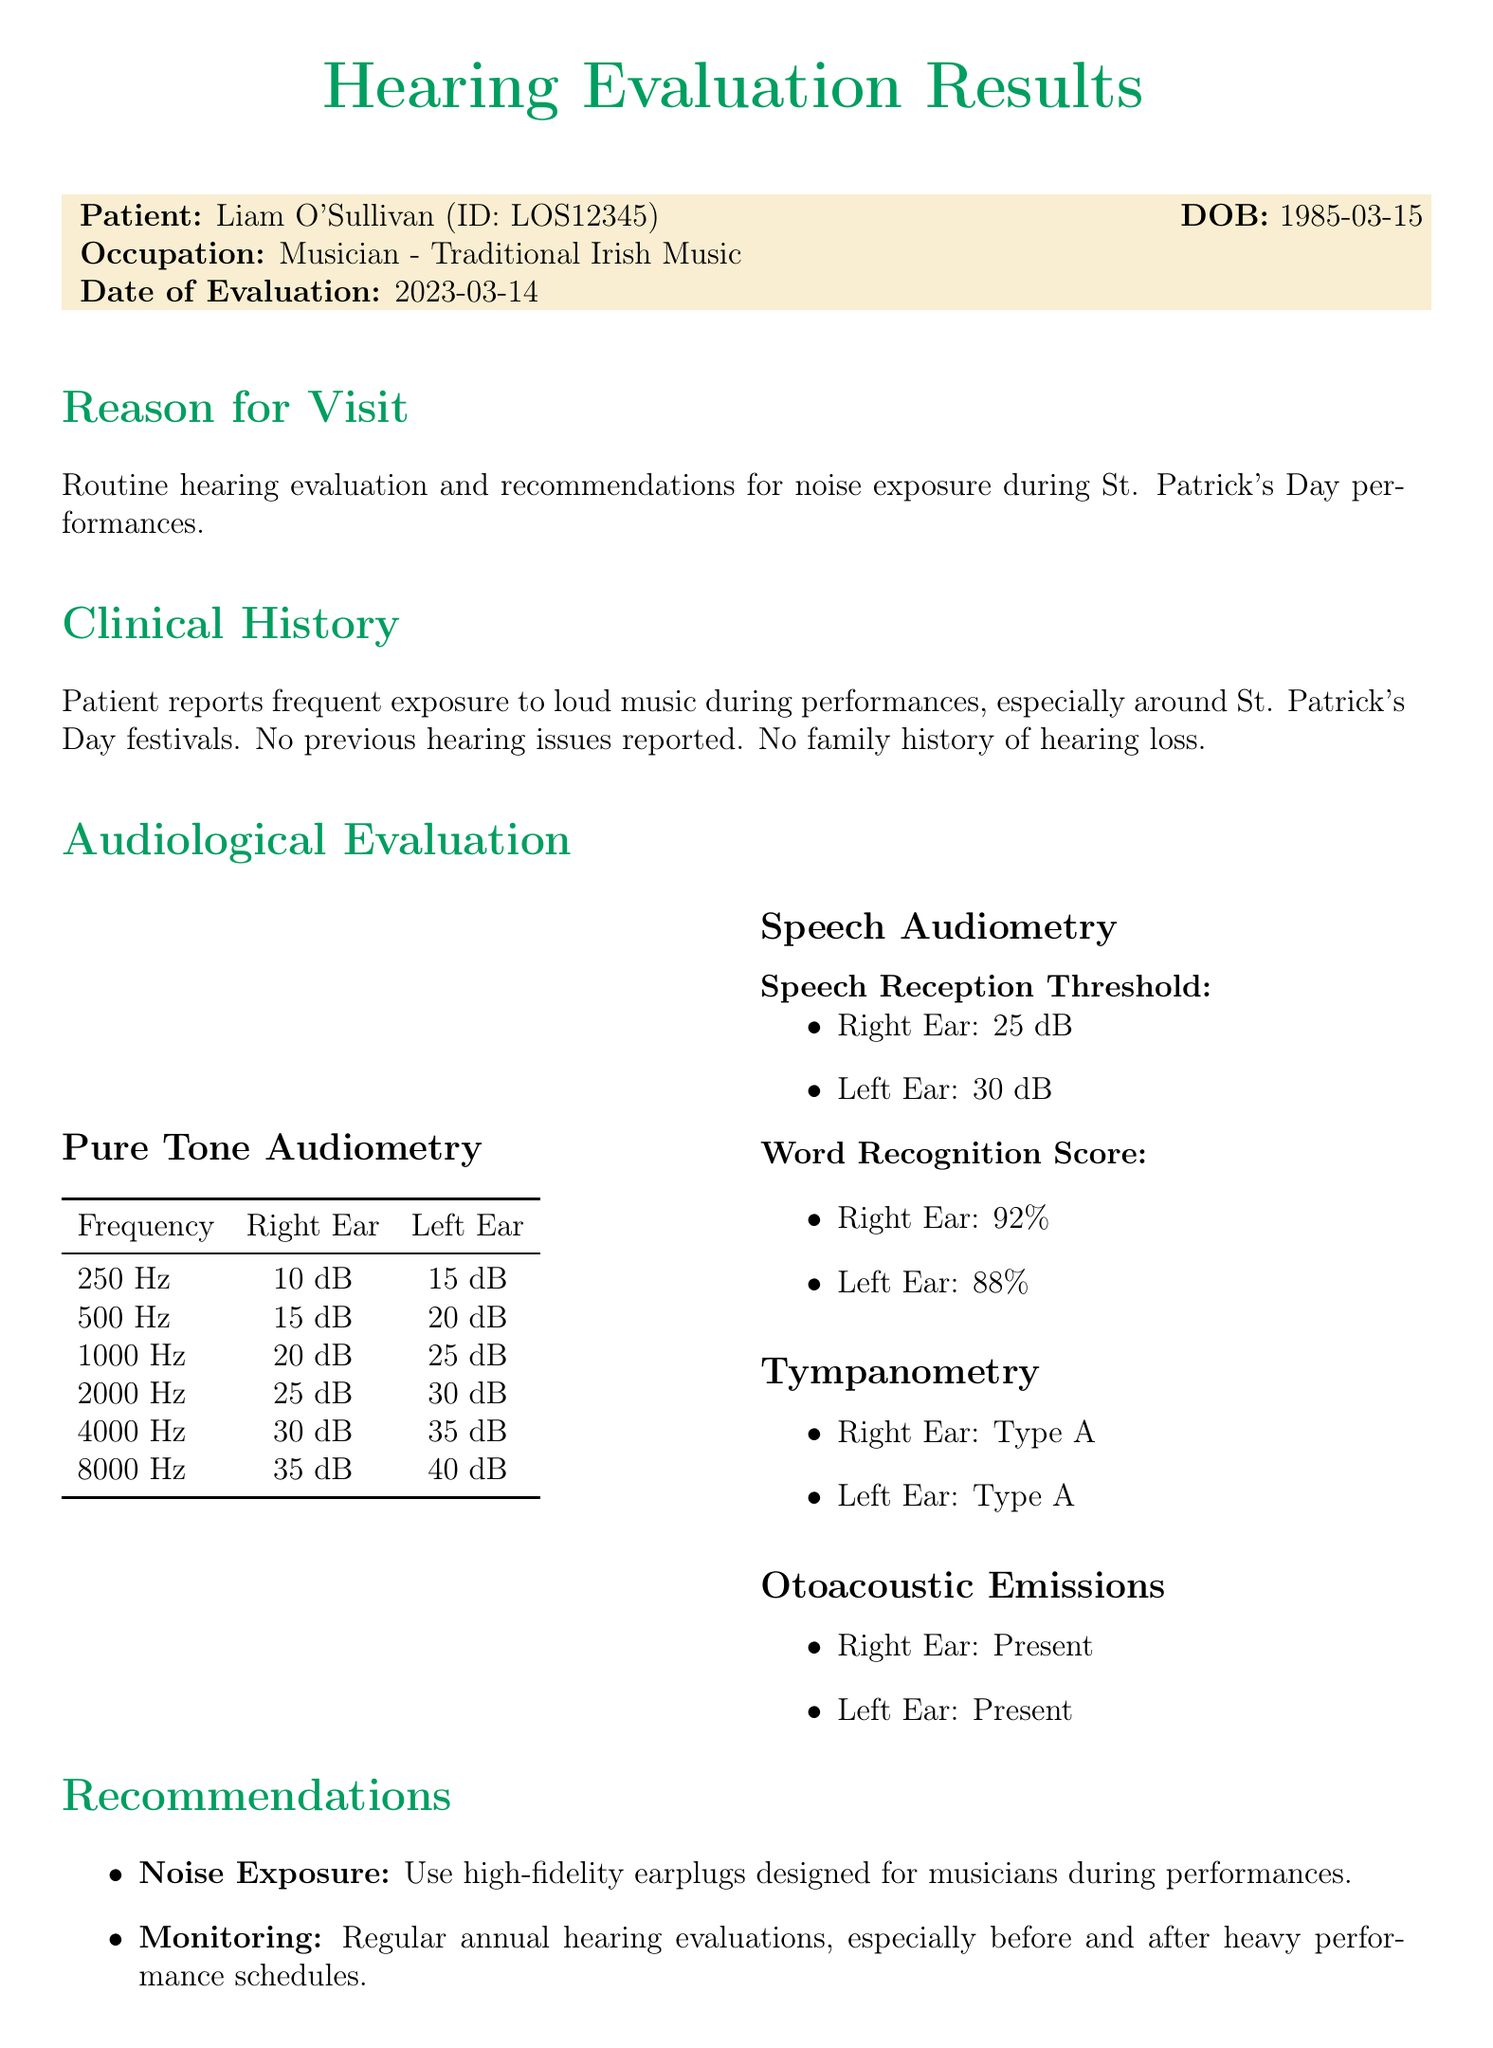what is the patient's name? The patient's name is provided at the beginning of the document.
Answer: Liam O'Sullivan what is the date of evaluation? The date of evaluation is mentioned in the patient's information.
Answer: 2023-03-14 what is the patient's occupation? The patient's occupation is listed in the medical record.
Answer: Musician - Traditional Irish Music what were the hearing thresholds at 4000 Hz for the right ear? The hearing thresholds are displayed in the audiological evaluation section.
Answer: 30 dB what is the word recognition score in the left ear? The score is specifically mentioned in the speech audiometry section.
Answer: 88% what recommendations are given for noise exposure? The document lists specific recommendations regarding noise exposure.
Answer: Use high-fidelity earplugs designed for musicians during performances how many decibels is the speech reception threshold for the right ear? The speech reception threshold is indicated in the speech audiometry section.
Answer: 25 dB what type of tympanometry results were recorded for both ears? The type of tympanometry results are stated in the document.
Answer: Type A what is the concluding remark about Liam's hearing? The concluding remarks summarize the findings and recommendations for Liam's hearing health.
Answer: Immediate protective measures and regular monitoring are essential for long-term auditory health 